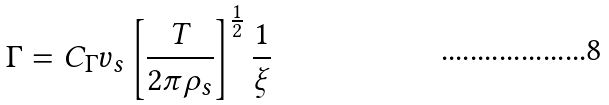Convert formula to latex. <formula><loc_0><loc_0><loc_500><loc_500>\Gamma = C _ { \Gamma } v _ { s } \left [ \frac { T } { 2 \pi \rho _ { s } } \right ] ^ { \frac { 1 } { 2 } } \frac { 1 } { \xi }</formula> 